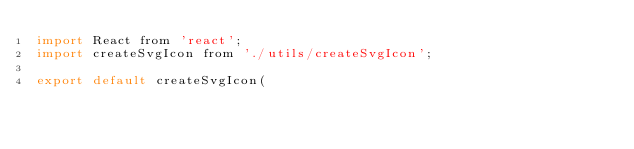<code> <loc_0><loc_0><loc_500><loc_500><_JavaScript_>import React from 'react';
import createSvgIcon from './utils/createSvgIcon';

export default createSvgIcon(</code> 